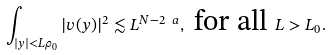<formula> <loc_0><loc_0><loc_500><loc_500>\int _ { | y | < L \rho _ { 0 } } | v ( y ) | ^ { 2 } \lesssim L ^ { N - 2 \ a } , \text { for all } L > L _ { 0 } .</formula> 